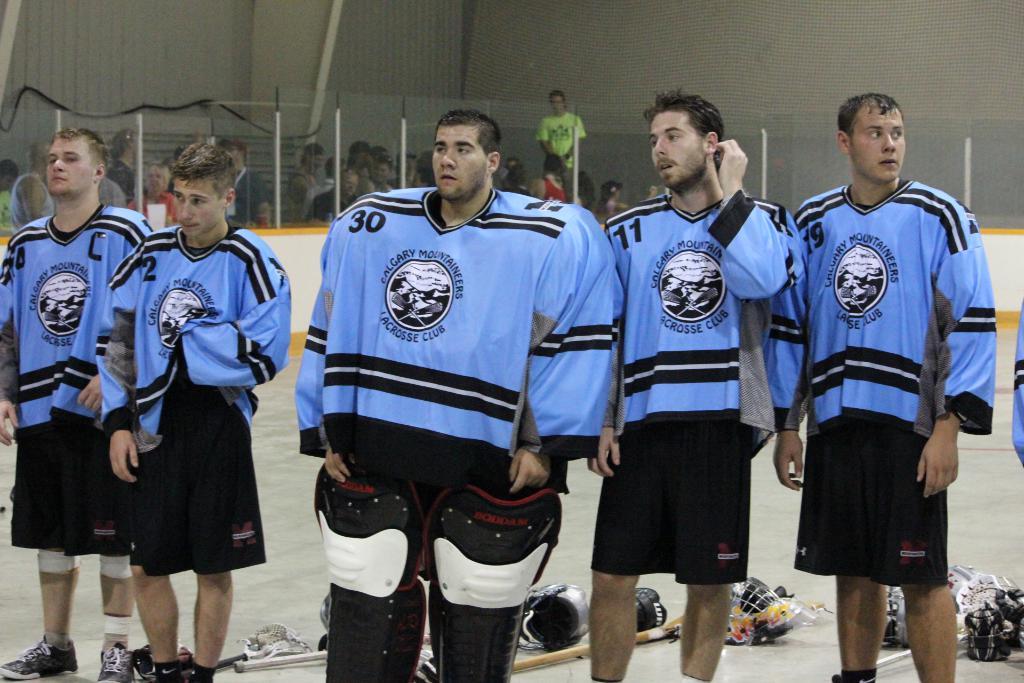What is the player number on the jersey of the middle player?
Keep it short and to the point. 30. 